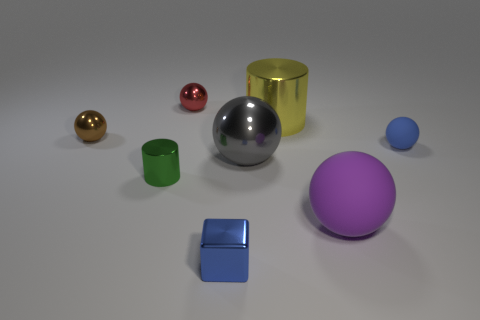Do the tiny block and the tiny rubber ball have the same color?
Make the answer very short. Yes. How many gray spheres are on the right side of the thing behind the metal cylinder that is behind the brown ball?
Ensure brevity in your answer.  1. There is a large sphere that is on the left side of the large cylinder; what is its color?
Your answer should be very brief. Gray. There is a tiny ball that is right of the small red metallic thing; is its color the same as the cube?
Offer a terse response. Yes. There is a yellow object that is the same shape as the green shiny thing; what size is it?
Give a very brief answer. Large. What material is the cube right of the small object that is to the left of the cylinder that is left of the red metallic thing made of?
Make the answer very short. Metal. Are there more red balls that are on the left side of the big purple thing than large matte things in front of the blue metallic thing?
Your response must be concise. Yes. Is the size of the purple matte object the same as the green metallic cylinder?
Provide a short and direct response. No. What is the color of the other big object that is the same shape as the big purple matte object?
Give a very brief answer. Gray. How many things are the same color as the metal block?
Your answer should be very brief. 1. 